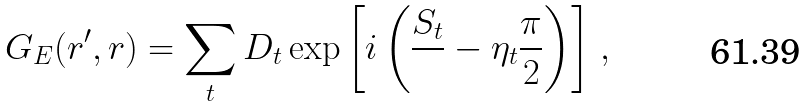Convert formula to latex. <formula><loc_0><loc_0><loc_500><loc_500>G _ { E } ( { r } ^ { \prime } , { r } ) = \sum _ { t } D _ { t } \exp { \left [ i \left ( \frac { S _ { t } } { } - \eta _ { t } \frac { \pi } { 2 } \right ) \right ] } \ ,</formula> 